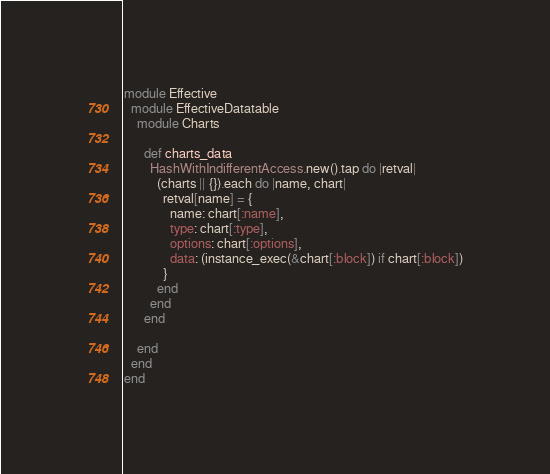<code> <loc_0><loc_0><loc_500><loc_500><_Ruby_>module Effective
  module EffectiveDatatable
    module Charts

      def charts_data
        HashWithIndifferentAccess.new().tap do |retval|
          (charts || {}).each do |name, chart|
            retval[name] = {
              name: chart[:name],
              type: chart[:type],
              options: chart[:options],
              data: (instance_exec(&chart[:block]) if chart[:block])
            }
          end
        end
      end

    end
  end
end
</code> 